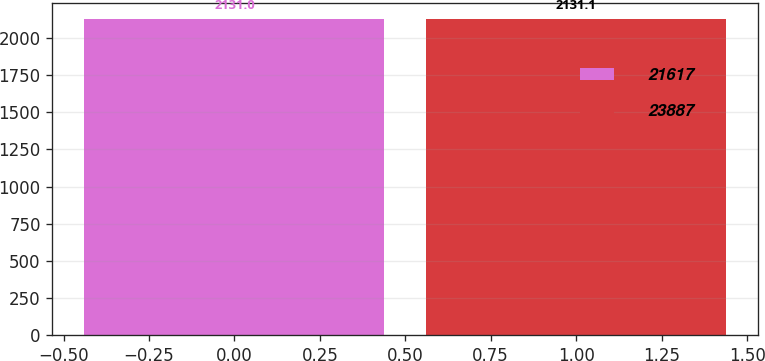Convert chart to OTSL. <chart><loc_0><loc_0><loc_500><loc_500><bar_chart><fcel>21617<fcel>23887<nl><fcel>2131<fcel>2131.1<nl></chart> 